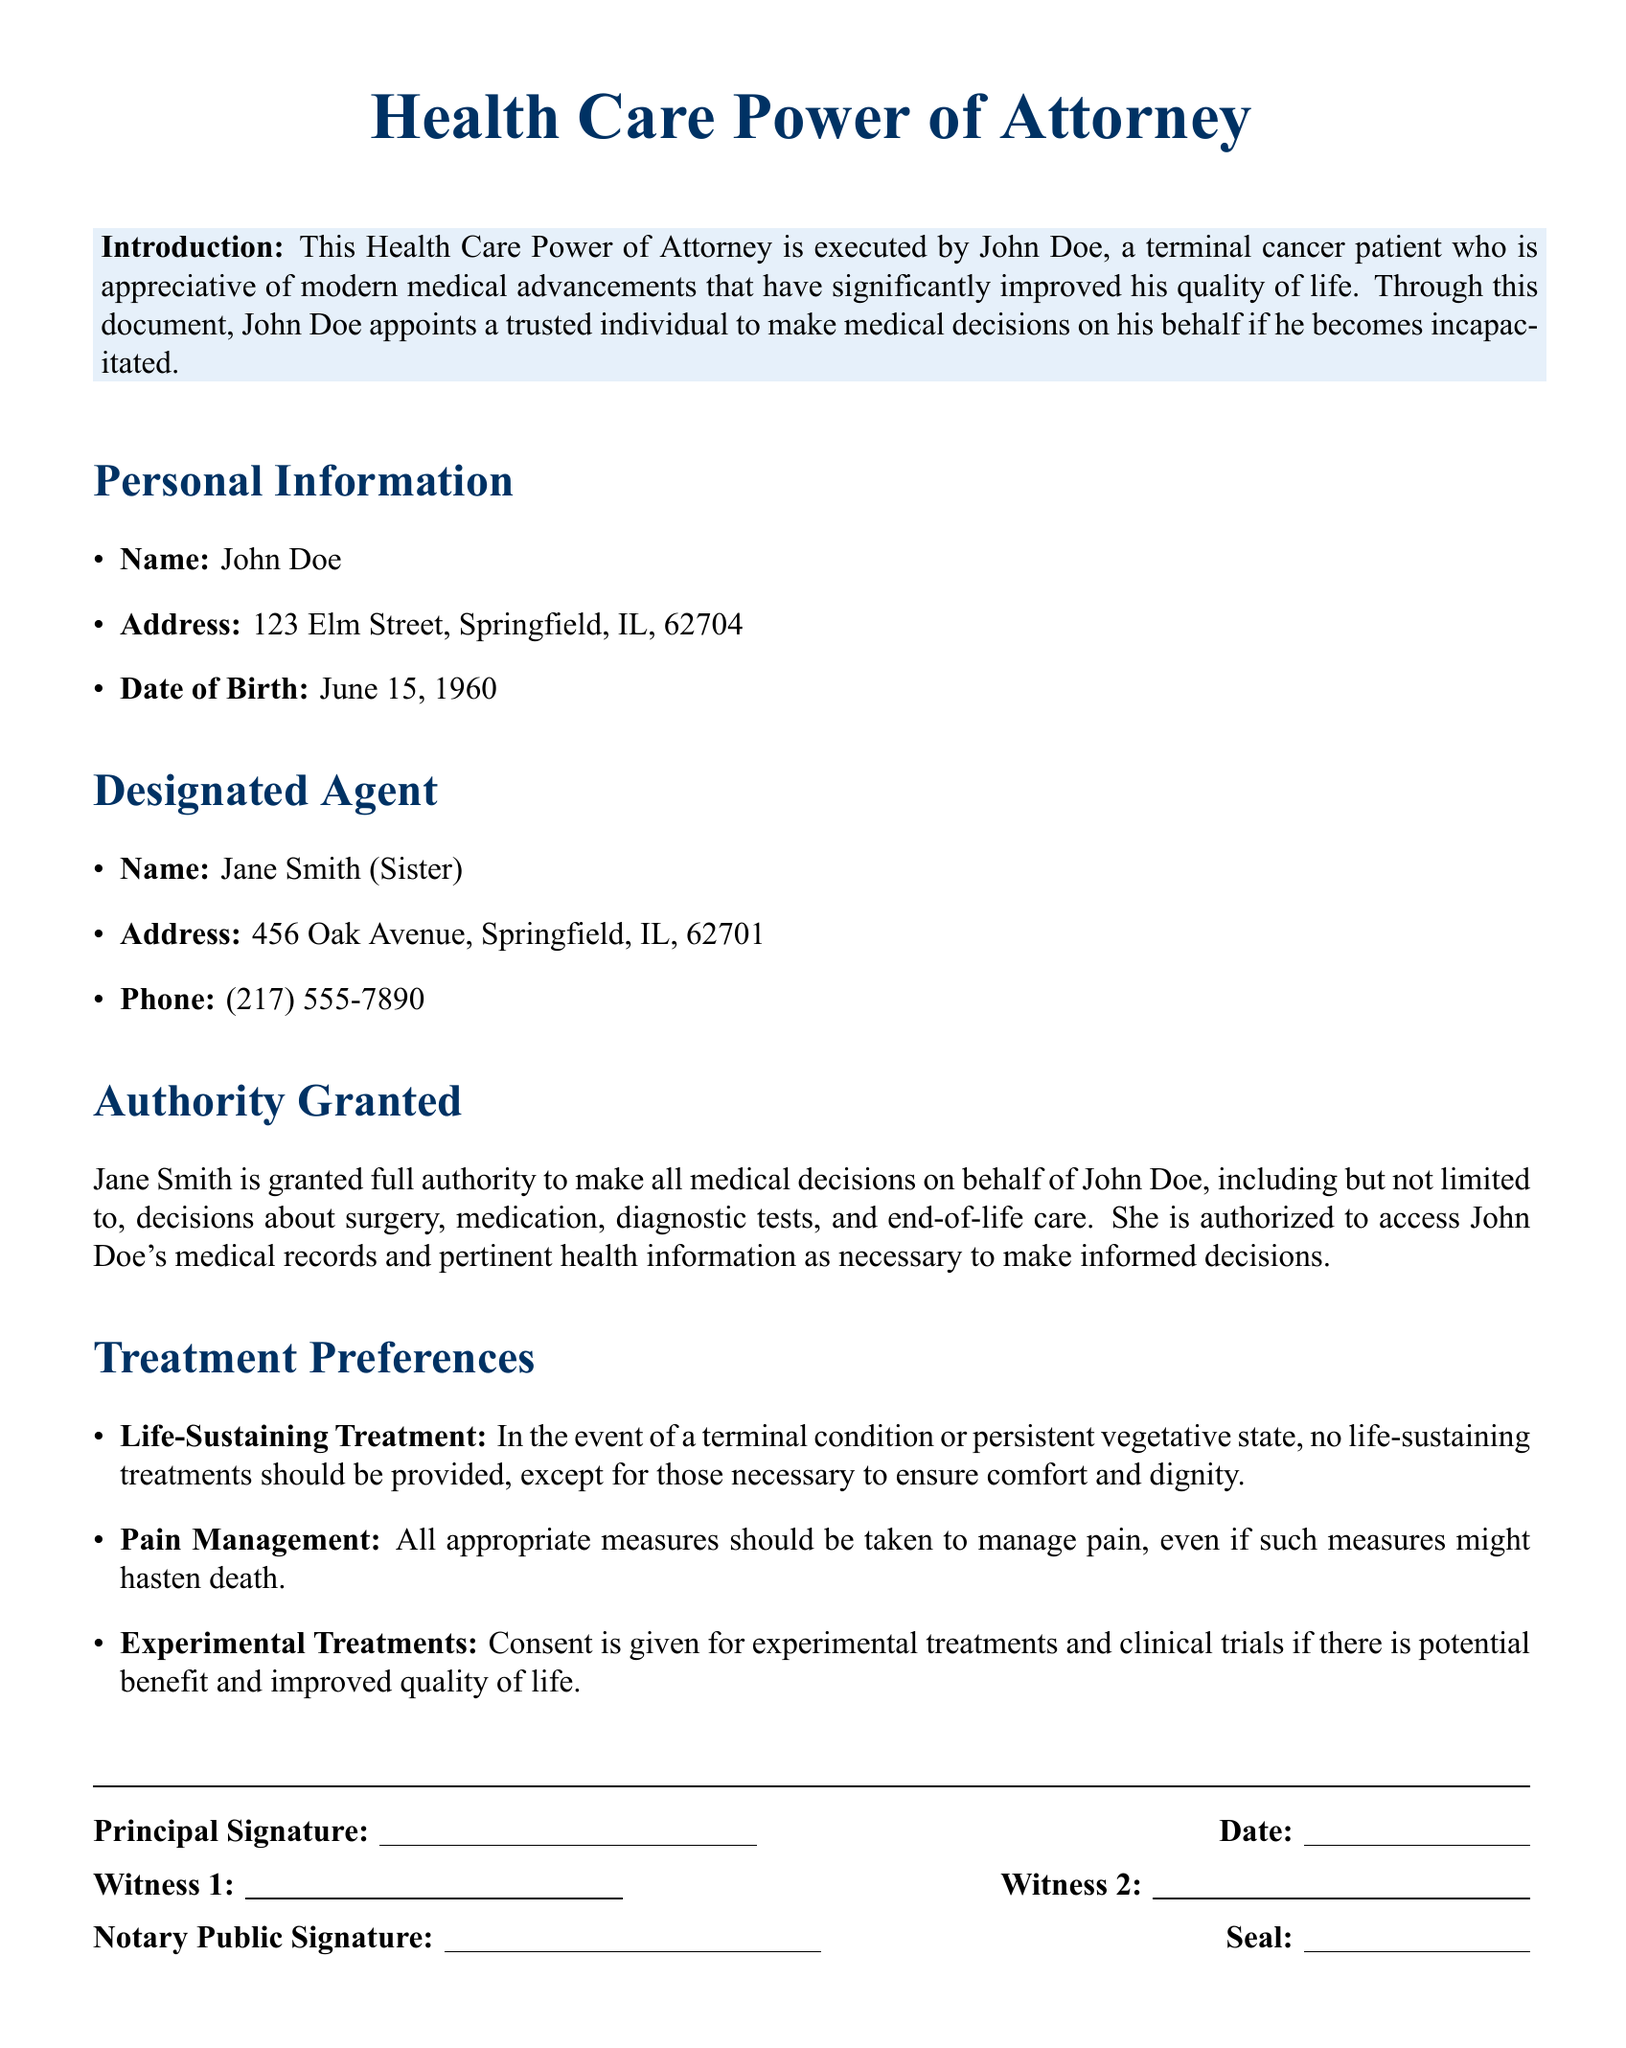What is the name of the principal? The principal is the person executing the Health Care Power of Attorney, which in this case is John Doe.
Answer: John Doe What is the date of birth of John Doe? The document explicitly states John Doe's date of birth for identification purposes.
Answer: June 15, 1960 Who is the designated agent? The designated agent is the individual appointed to make medical decisions on behalf of John Doe, as named in the document.
Answer: Jane Smith What is Jane Smith's relationship to John Doe? The relationship is specified in the document, clarifying her role in making medical decisions.
Answer: Sister What authority is granted to Jane Smith? The document outlines the extent of authority that Jane Smith has in making medical decisions for John Doe.
Answer: Full authority What is stated about life-sustaining treatments? The document specifies preferences regarding the provision of life-sustaining treatments in certain medical situations.
Answer: No life-sustaining treatments What is John Doe's preference for pain management? The document indicates specific measures that John Doe wishes to be taken for managing pain.
Answer: All appropriate measures Is consent given for experimental treatments? The document outlines whether John Doe consents to participate in experimental treatments or clinical trials.
Answer: Consent is given What needs to be done to John Doe's medical records? The authority section specifies what Jane Smith can do in relation to John Doe's medical records.
Answer: Access as necessary 